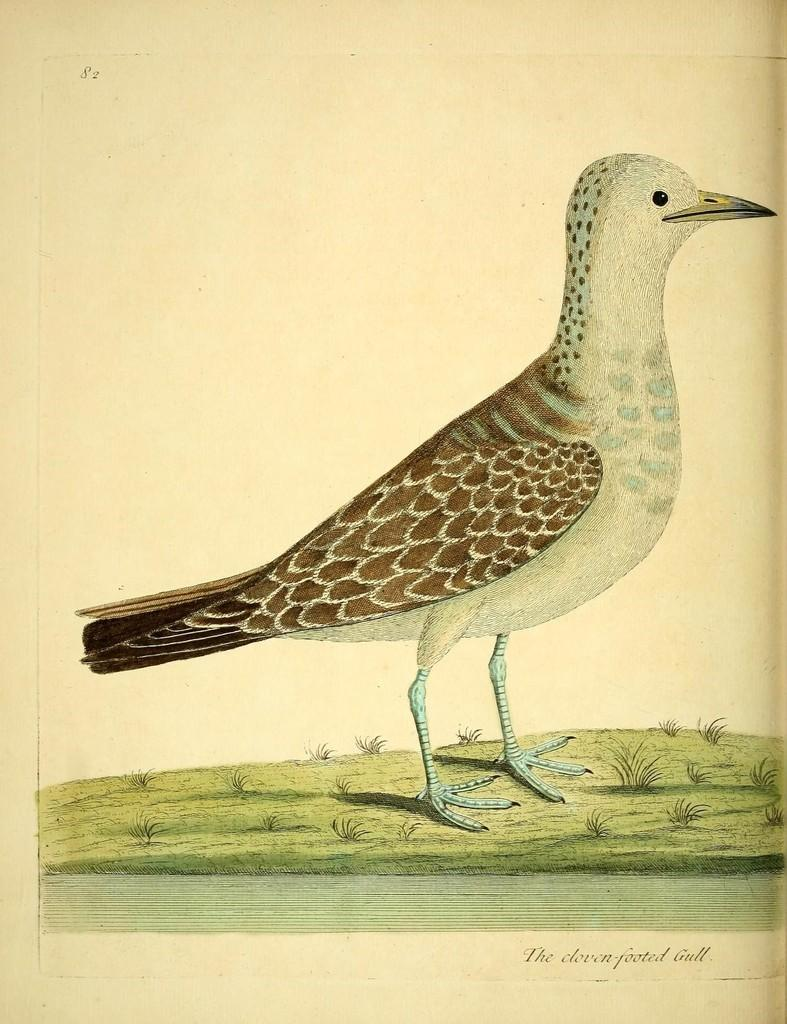What is present in the image? There is a poster in the image. What is depicted on the poster? The poster features a bird. What is the taste of the soda in the image? There is no soda present in the image; it only features a poster with a bird. 